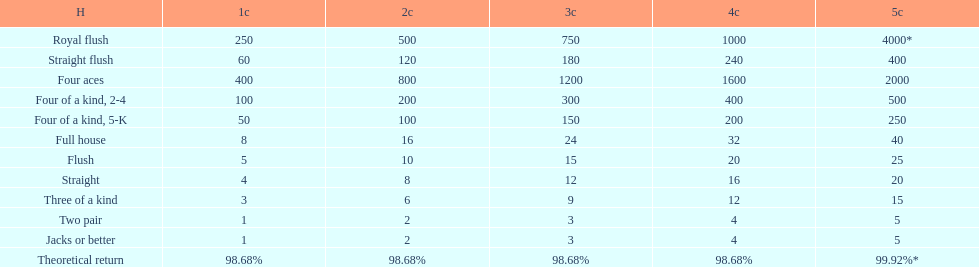How many credits do you have to spend to get at least 2000 in payout if you had four aces? 5 credits. 